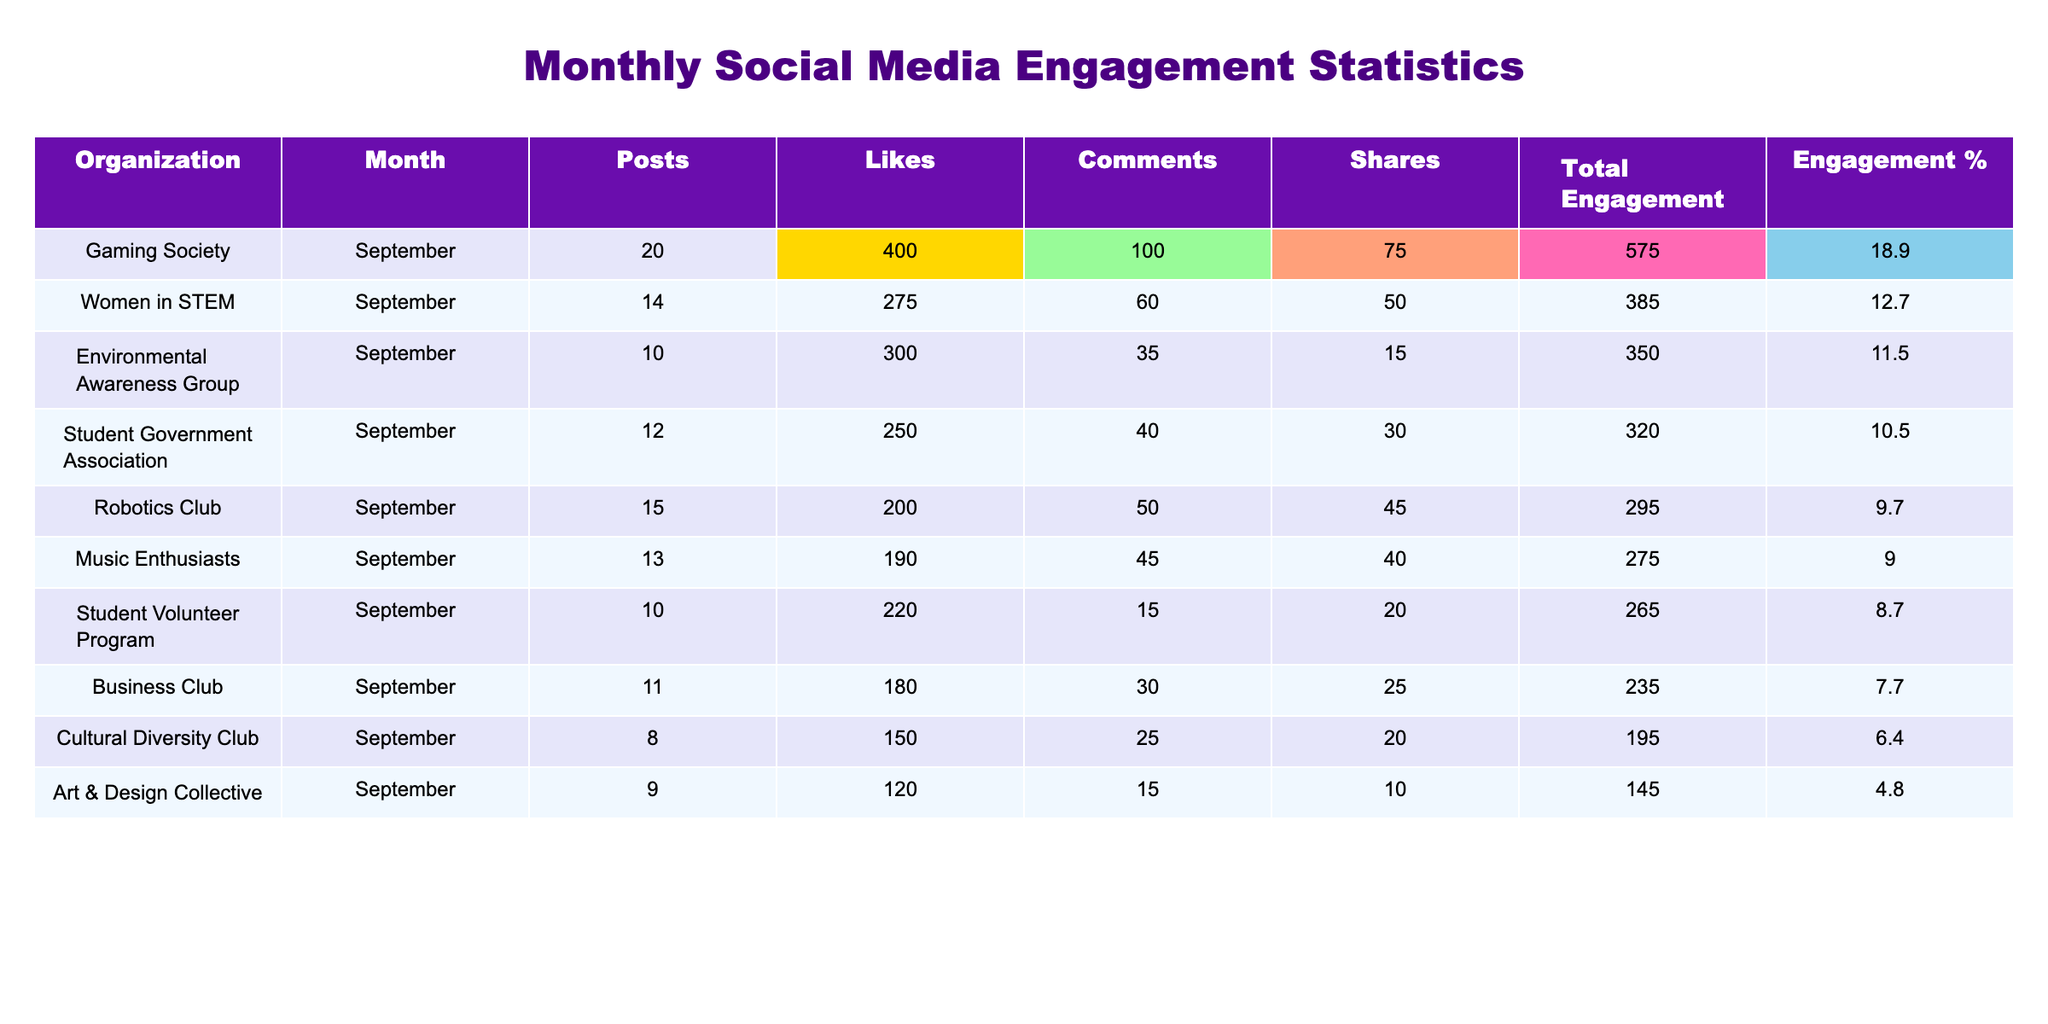What is the total engagement for the Gaming Society? Looking at the "Total Engagement" column for the Gaming Society, the value is 575.
Answer: 575 Which organization had the highest number of likes in September? The "Likes" column shows that the Gaming Society had the highest number of likes, with a total of 400.
Answer: Gaming Society Does the Women in STEM organization have more comments than the Environmental Awareness Group? The Women in STEM received 60 comments while the Environmental Awareness Group received 35 comments. Therefore, Women in STEM has more comments.
Answer: Yes What is the total number of posts made by all organizations in September? To find this, sum the "Posts" column: 12 + 8 + 10 + 15 + 14 + 20 + 9 + 11 + 10 + 13 =  132.
Answer: 132 Which organization had the lowest total engagement and how much was it? Looking at the "Total Engagement" column, the Art & Design Collective had the lowest engagement at 145.
Answer: Art & Design Collective, 145 What is the average number of shares across all organizations? To compute the average number of shares, sum the "Shares" column: 30 + 20 + 15 + 45 + 50 + 75 + 10 + 25 + 20 + 40 =  330. Divide by 10 organizations gives 330/10 = 33.
Answer: 33 Which organization had more total engagement, the Cultural Diversity Club or the Business Club? The Cultural Diversity Club had 195 total engagements while the Business Club had 235. Thus, the Business Club had more engagement.
Answer: Business Club What percentage of total engagement did the Student Government Association contribute? First, calculate the total engagement, which is 2,765. Then, 320 (the Student Government Association's engagement) divided by 2,765 and multiplied by 100 gives approximately 11.6%.
Answer: 11.6% What are the total engagements for the top three organizations? The top three organizations by engagement are Gaming Society (575), Women in STEM (385), and Environmental Awareness Group (350). Adding these yields 575 + 385 + 350 = 1,310.
Answer: 1,310 How many more comments did the Gaming Society receive compared to the Music Enthusiasts? The Gaming Society received 100 comments while the Music Enthusiasts received 45, leading to a difference of 100 - 45 = 55 comments.
Answer: 55 